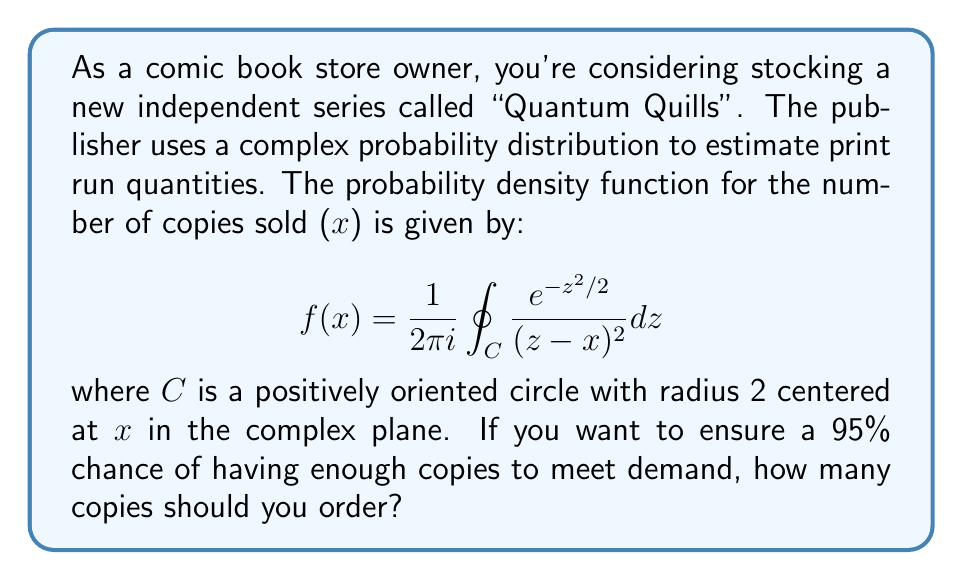Could you help me with this problem? To solve this problem, we need to follow these steps:

1) First, we recognize that this probability density function is related to the standard normal distribution. The integral in the complex plane is a representation of the cumulative distribution function (CDF) of the standard normal distribution.

2) The CDF of the standard normal distribution at a point x is given by:

   $$\Phi(x) = \frac{1}{2\pi i} \oint_C \frac{e^{-z^2/2}}{z-x} dz$$

3) The probability density function given in the question is the derivative of this CDF:

   $$f(x) = \Phi'(x) = \frac{1}{2\pi i} \oint_C \frac{e^{-z^2/2}}{(z-x)^2} dz$$

4) This means that the number of copies sold follows a standard normal distribution N(0,1).

5) To ensure a 95% chance of having enough copies, we need to find the 95th percentile of this distribution.

6) For a standard normal distribution, the 95th percentile is approximately 1.645 standard deviations above the mean.

7) Since this is a standard normal distribution (mean = 0, standard deviation = 1), the number of copies we should order is:

   $$x = 0 + 1.645 * 1 = 1.645$$

8) However, since we can't order a fractional number of comics, we need to round up to the nearest whole number.
Answer: You should order 2 copies of "Quantum Quills" to ensure a 95% chance of meeting demand. 